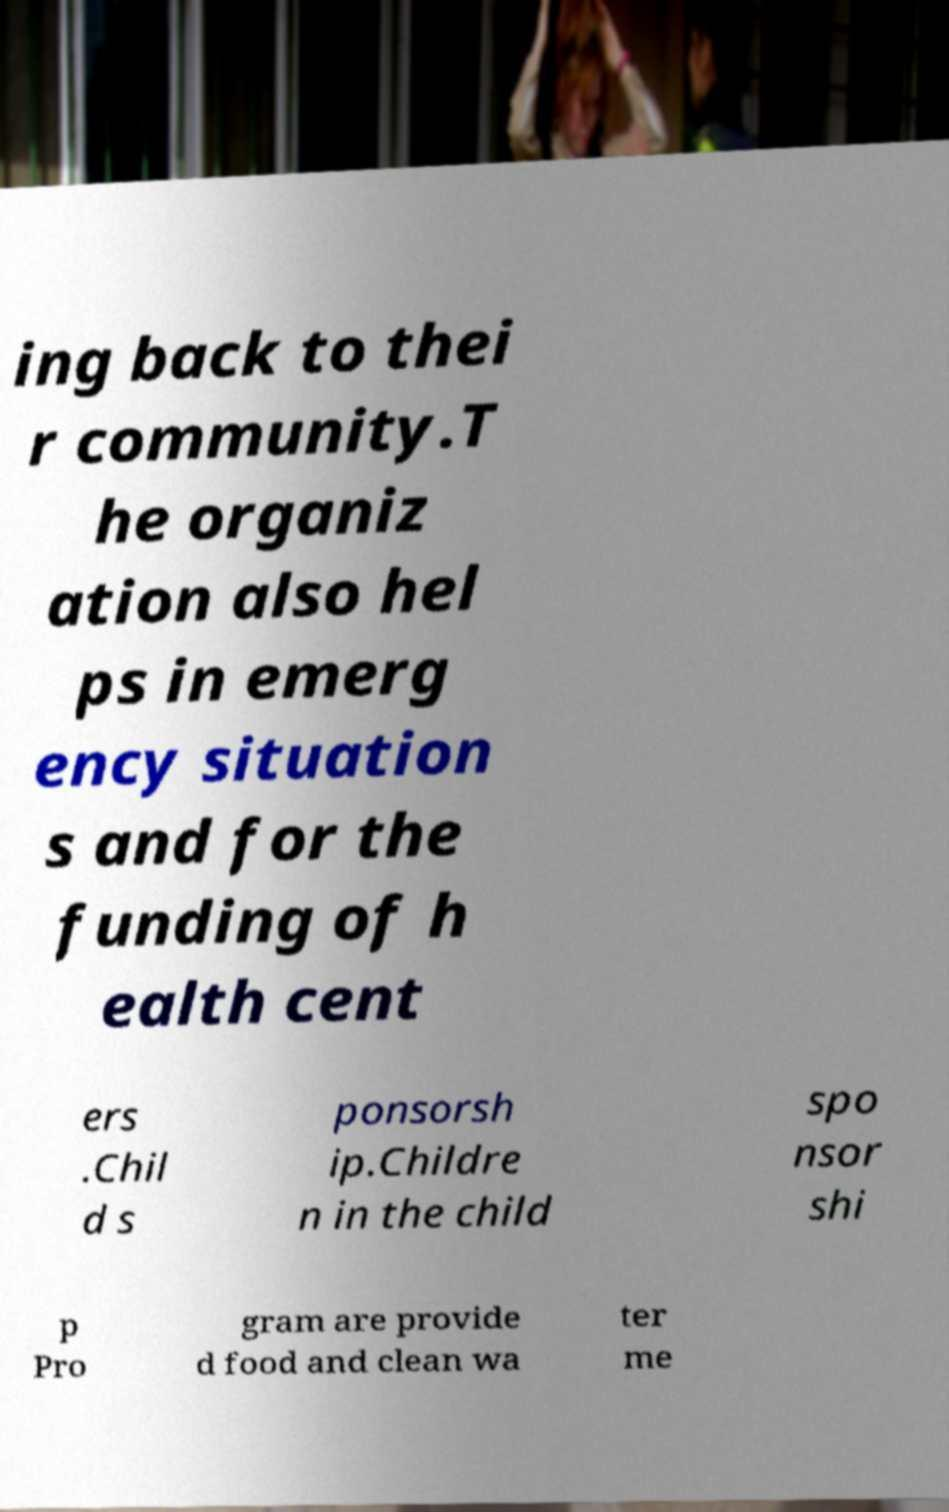Could you extract and type out the text from this image? ing back to thei r community.T he organiz ation also hel ps in emerg ency situation s and for the funding of h ealth cent ers .Chil d s ponsorsh ip.Childre n in the child spo nsor shi p Pro gram are provide d food and clean wa ter me 